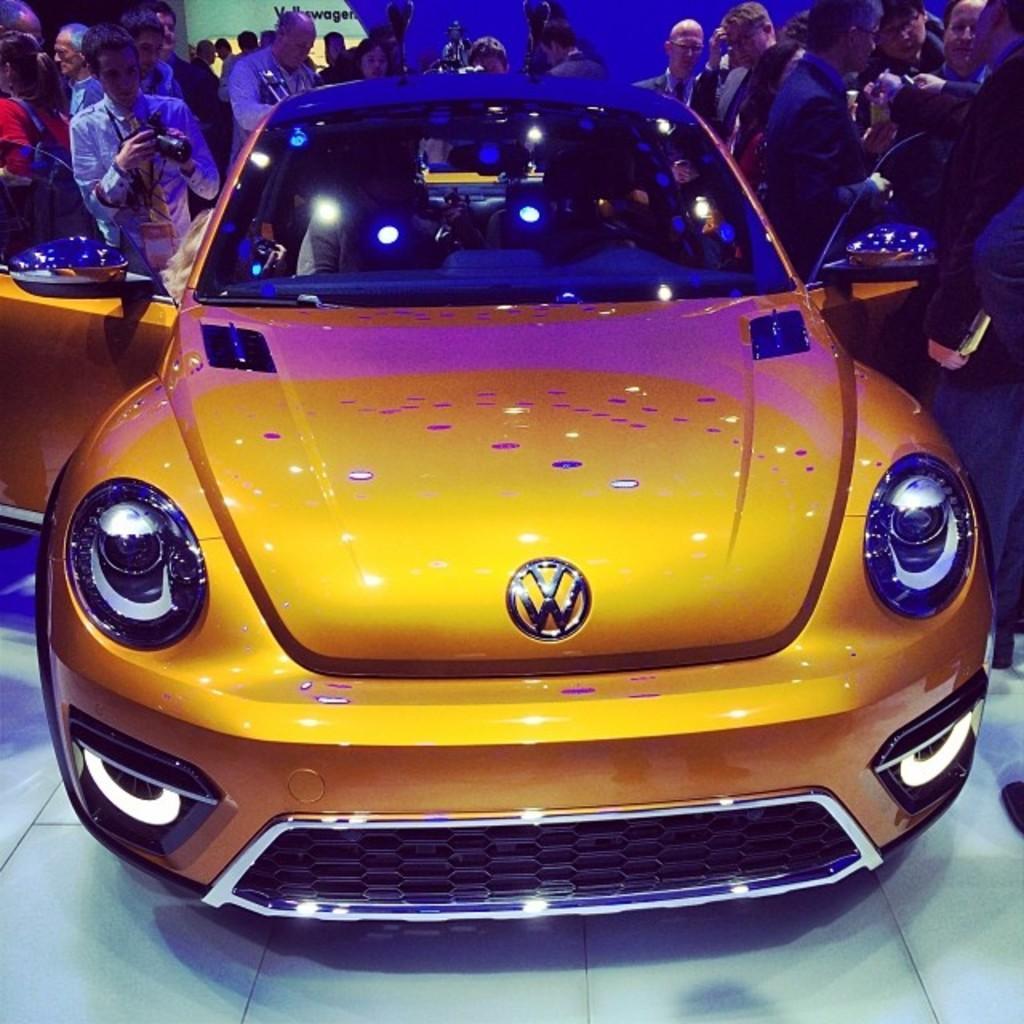Can you describe this image briefly? In this image I see a car which is of orange in color and I see the logo over here and I see number of people who are around the car and I see the floor and I see this man is holding a camera and over here I see the lights on the glass. 